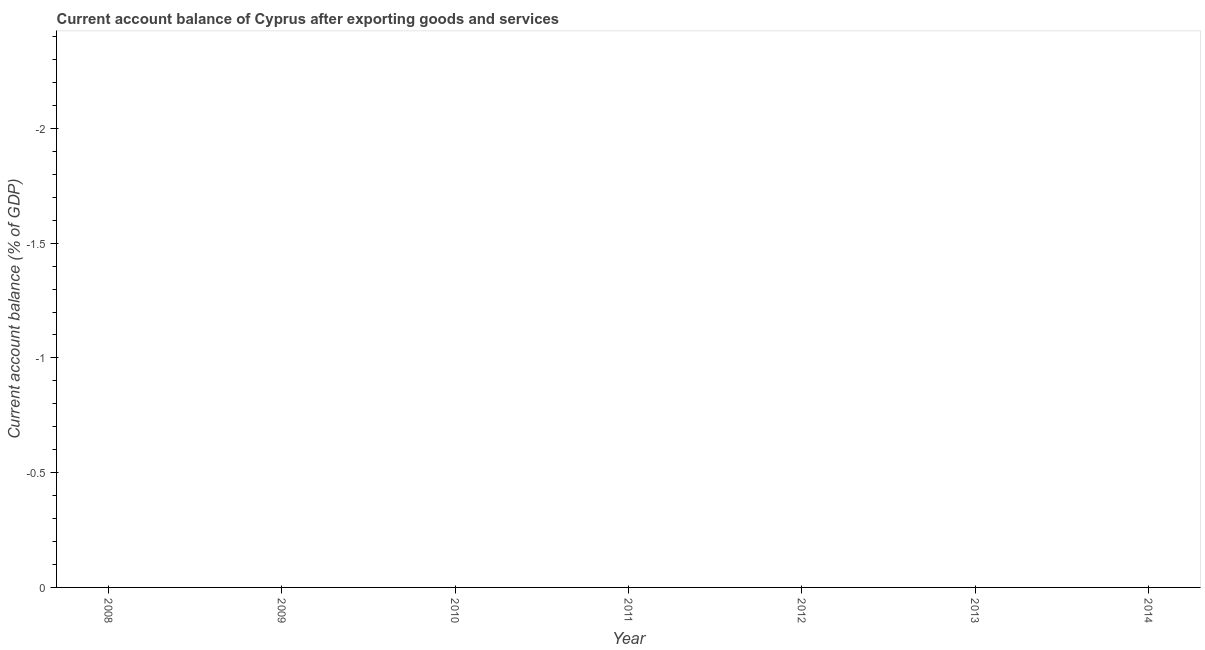What is the current account balance in 2009?
Ensure brevity in your answer.  0. What is the average current account balance per year?
Make the answer very short. 0. What is the median current account balance?
Provide a succinct answer. 0. How many dotlines are there?
Your response must be concise. 0. How many years are there in the graph?
Offer a terse response. 7. What is the difference between two consecutive major ticks on the Y-axis?
Your answer should be compact. 0.5. Does the graph contain any zero values?
Ensure brevity in your answer.  Yes. Does the graph contain grids?
Provide a short and direct response. No. What is the title of the graph?
Keep it short and to the point. Current account balance of Cyprus after exporting goods and services. What is the label or title of the X-axis?
Make the answer very short. Year. What is the label or title of the Y-axis?
Provide a short and direct response. Current account balance (% of GDP). What is the Current account balance (% of GDP) in 2009?
Give a very brief answer. 0. What is the Current account balance (% of GDP) in 2010?
Make the answer very short. 0. What is the Current account balance (% of GDP) in 2012?
Your answer should be compact. 0. What is the Current account balance (% of GDP) in 2013?
Your answer should be compact. 0. What is the Current account balance (% of GDP) in 2014?
Your response must be concise. 0. 